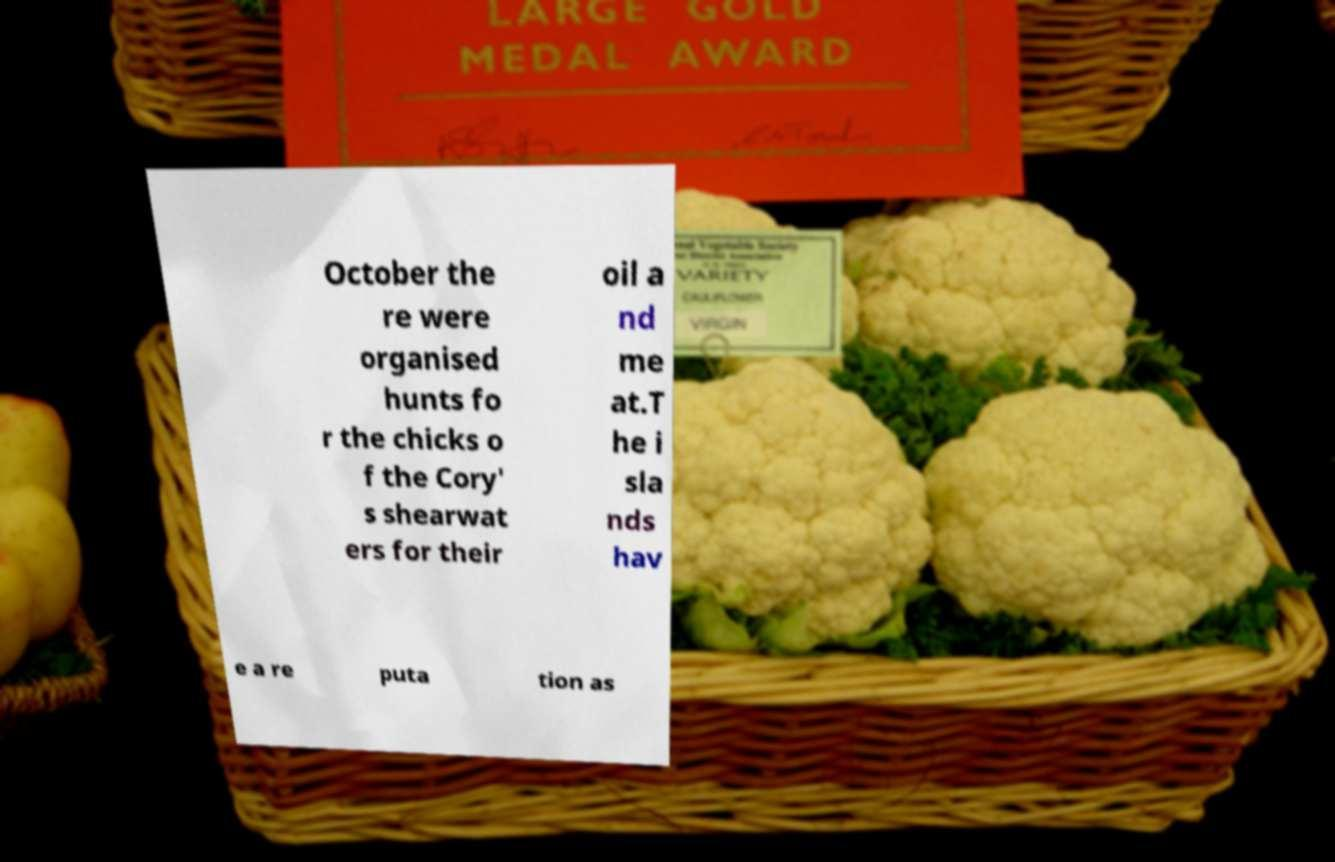For documentation purposes, I need the text within this image transcribed. Could you provide that? October the re were organised hunts fo r the chicks o f the Cory' s shearwat ers for their oil a nd me at.T he i sla nds hav e a re puta tion as 